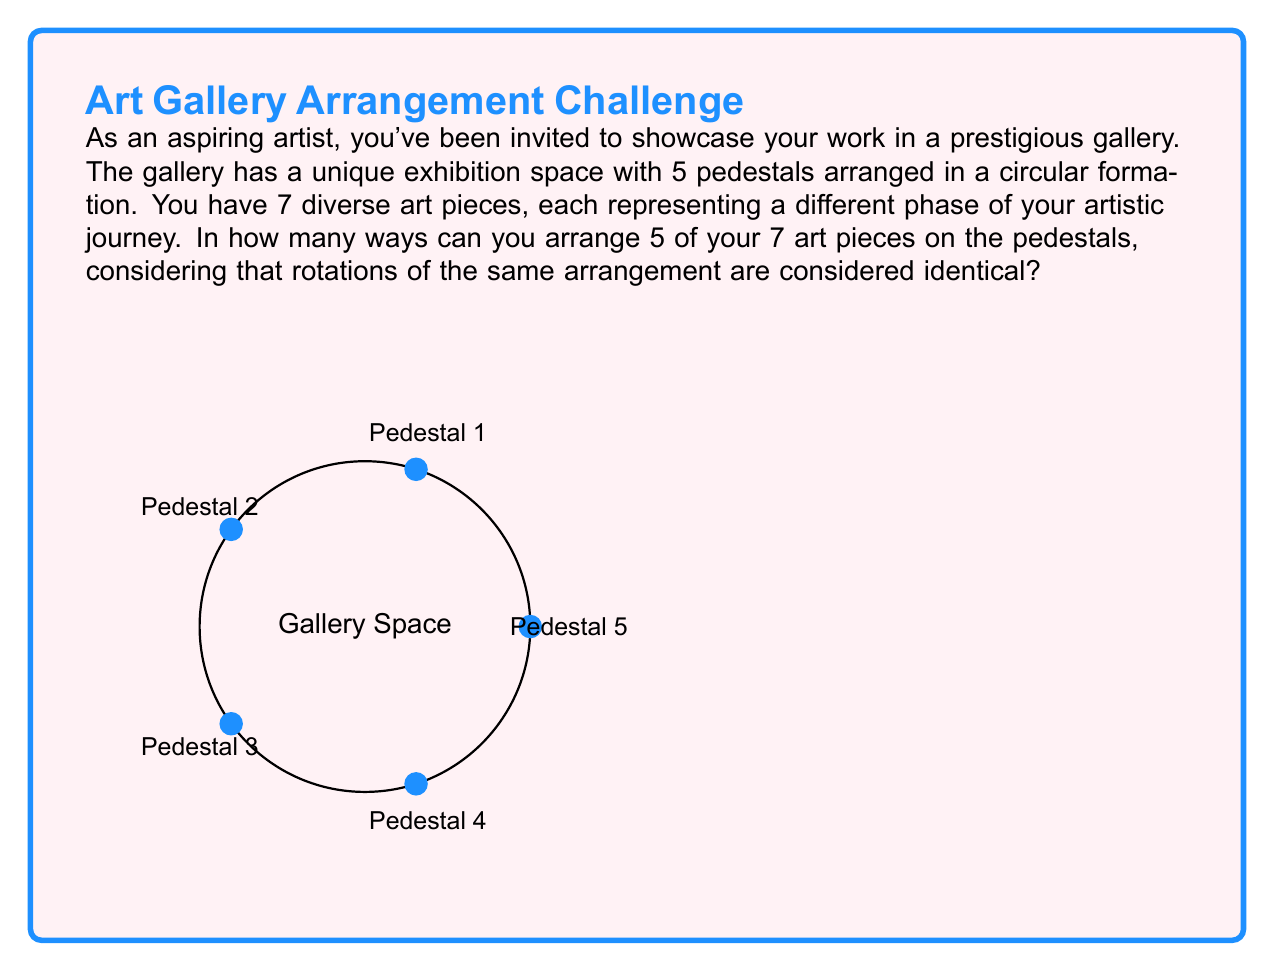What is the answer to this math problem? Let's approach this step-by-step:

1) First, we need to choose 5 art pieces out of 7. This is a combination problem, denoted as $\binom{7}{5}$ or $C(7,5)$.

   $$\binom{7}{5} = \frac{7!}{5!(7-5)!} = \frac{7!}{5!2!} = 21$$

2) Now, for each selection of 5 pieces, we need to arrange them on the pedestals. Normally, this would be a permutation of 5, which is 5!.

3) However, since the pedestals are arranged in a circle, rotations of the same arrangement are considered identical. This means we need to divide by the number of possible rotations, which is 5 (as there are 5 pedestals).

4) Therefore, for each selection of 5 pieces, the number of unique arrangements is:

   $$\frac{5!}{5} = 24$$

5) By the multiplication principle, we multiply the number of ways to select 5 pieces by the number of ways to arrange them:

   $$21 \times 24 = 504$$

Thus, there are 504 possible ways to arrange 5 of your 7 art pieces on the circular arrangement of pedestals.
Answer: 504 